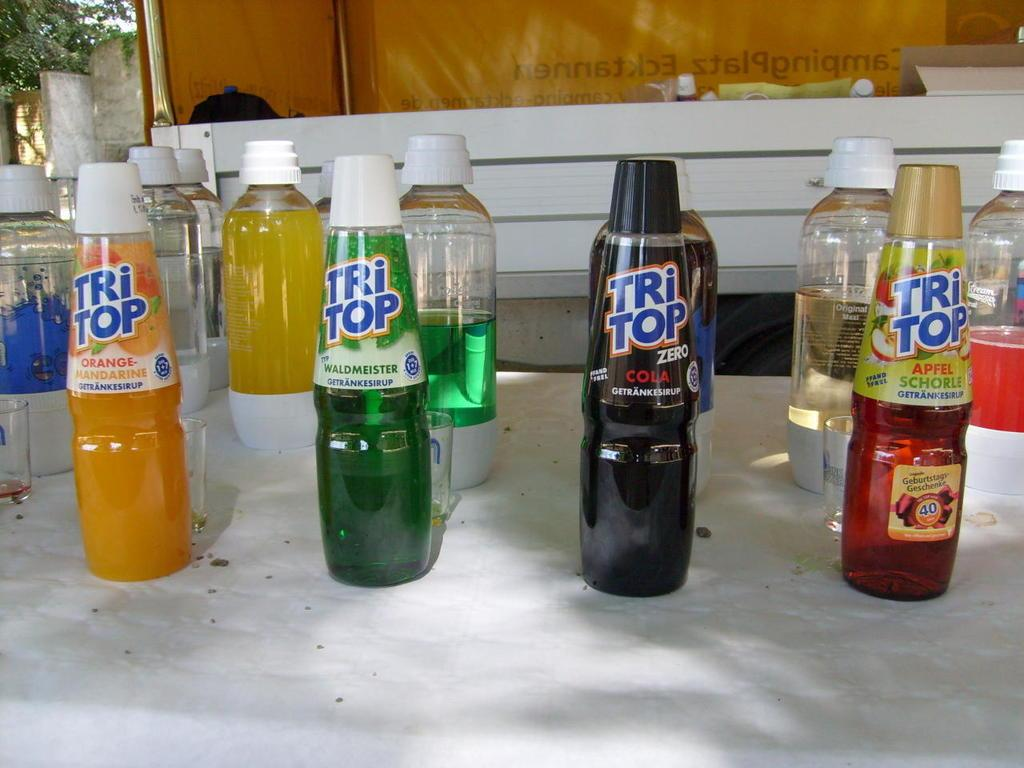<image>
Share a concise interpretation of the image provided. Four bottles of Tri Top are arranged on a table outside. 